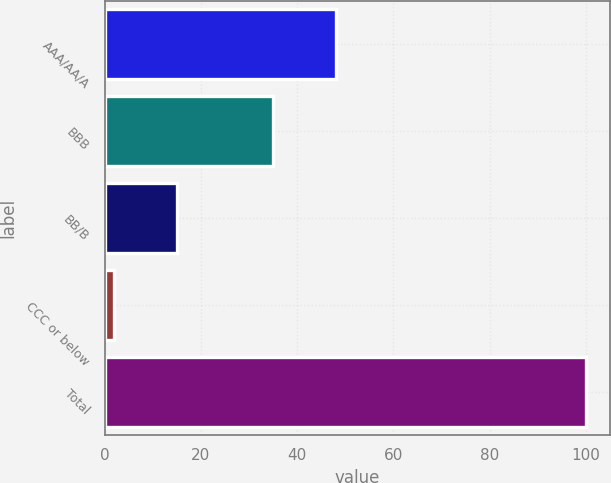Convert chart to OTSL. <chart><loc_0><loc_0><loc_500><loc_500><bar_chart><fcel>AAA/AA/A<fcel>BBB<fcel>BB/B<fcel>CCC or below<fcel>Total<nl><fcel>48<fcel>35<fcel>15<fcel>2<fcel>100<nl></chart> 